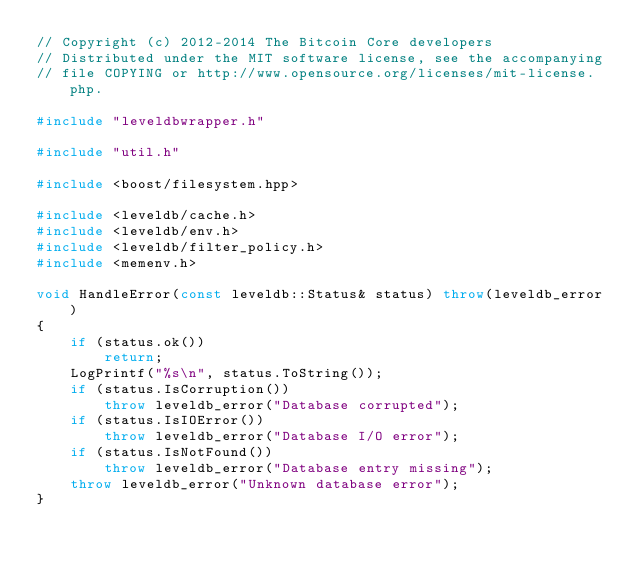<code> <loc_0><loc_0><loc_500><loc_500><_C++_>// Copyright (c) 2012-2014 The Bitcoin Core developers
// Distributed under the MIT software license, see the accompanying
// file COPYING or http://www.opensource.org/licenses/mit-license.php.

#include "leveldbwrapper.h"

#include "util.h"

#include <boost/filesystem.hpp>

#include <leveldb/cache.h>
#include <leveldb/env.h>
#include <leveldb/filter_policy.h>
#include <memenv.h>

void HandleError(const leveldb::Status& status) throw(leveldb_error)
{
    if (status.ok())
        return;
    LogPrintf("%s\n", status.ToString());
    if (status.IsCorruption())
        throw leveldb_error("Database corrupted");
    if (status.IsIOError())
        throw leveldb_error("Database I/O error");
    if (status.IsNotFound())
        throw leveldb_error("Database entry missing");
    throw leveldb_error("Unknown database error");
}
</code> 